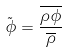<formula> <loc_0><loc_0><loc_500><loc_500>\tilde { \phi } = \frac { \overline { \rho \phi } } { \overline { \rho } }</formula> 